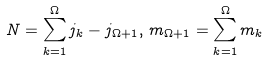Convert formula to latex. <formula><loc_0><loc_0><loc_500><loc_500>N = \sum _ { k = 1 } ^ { \Omega } j _ { k } - j _ { \Omega + 1 } , \, m _ { \Omega + 1 } = \sum _ { k = 1 } ^ { \Omega } m _ { k }</formula> 